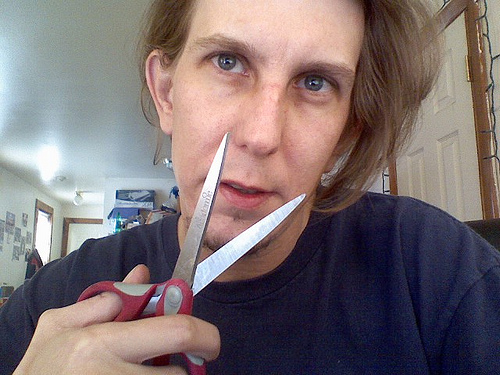How many white cars are on the road? I apologize for the oversight, but there are actually no white cars visible in the image provided. The photo depicts an individual indoors holding scissors close to their nose, not a road with cars. 